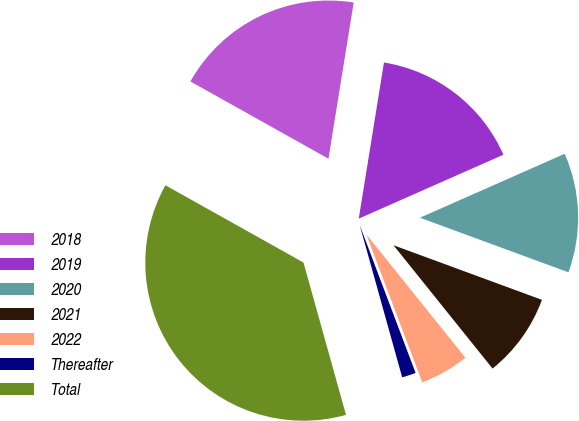<chart> <loc_0><loc_0><loc_500><loc_500><pie_chart><fcel>2018<fcel>2019<fcel>2020<fcel>2021<fcel>2022<fcel>Thereafter<fcel>Total<nl><fcel>19.43%<fcel>15.83%<fcel>12.23%<fcel>8.62%<fcel>5.02%<fcel>1.42%<fcel>37.45%<nl></chart> 